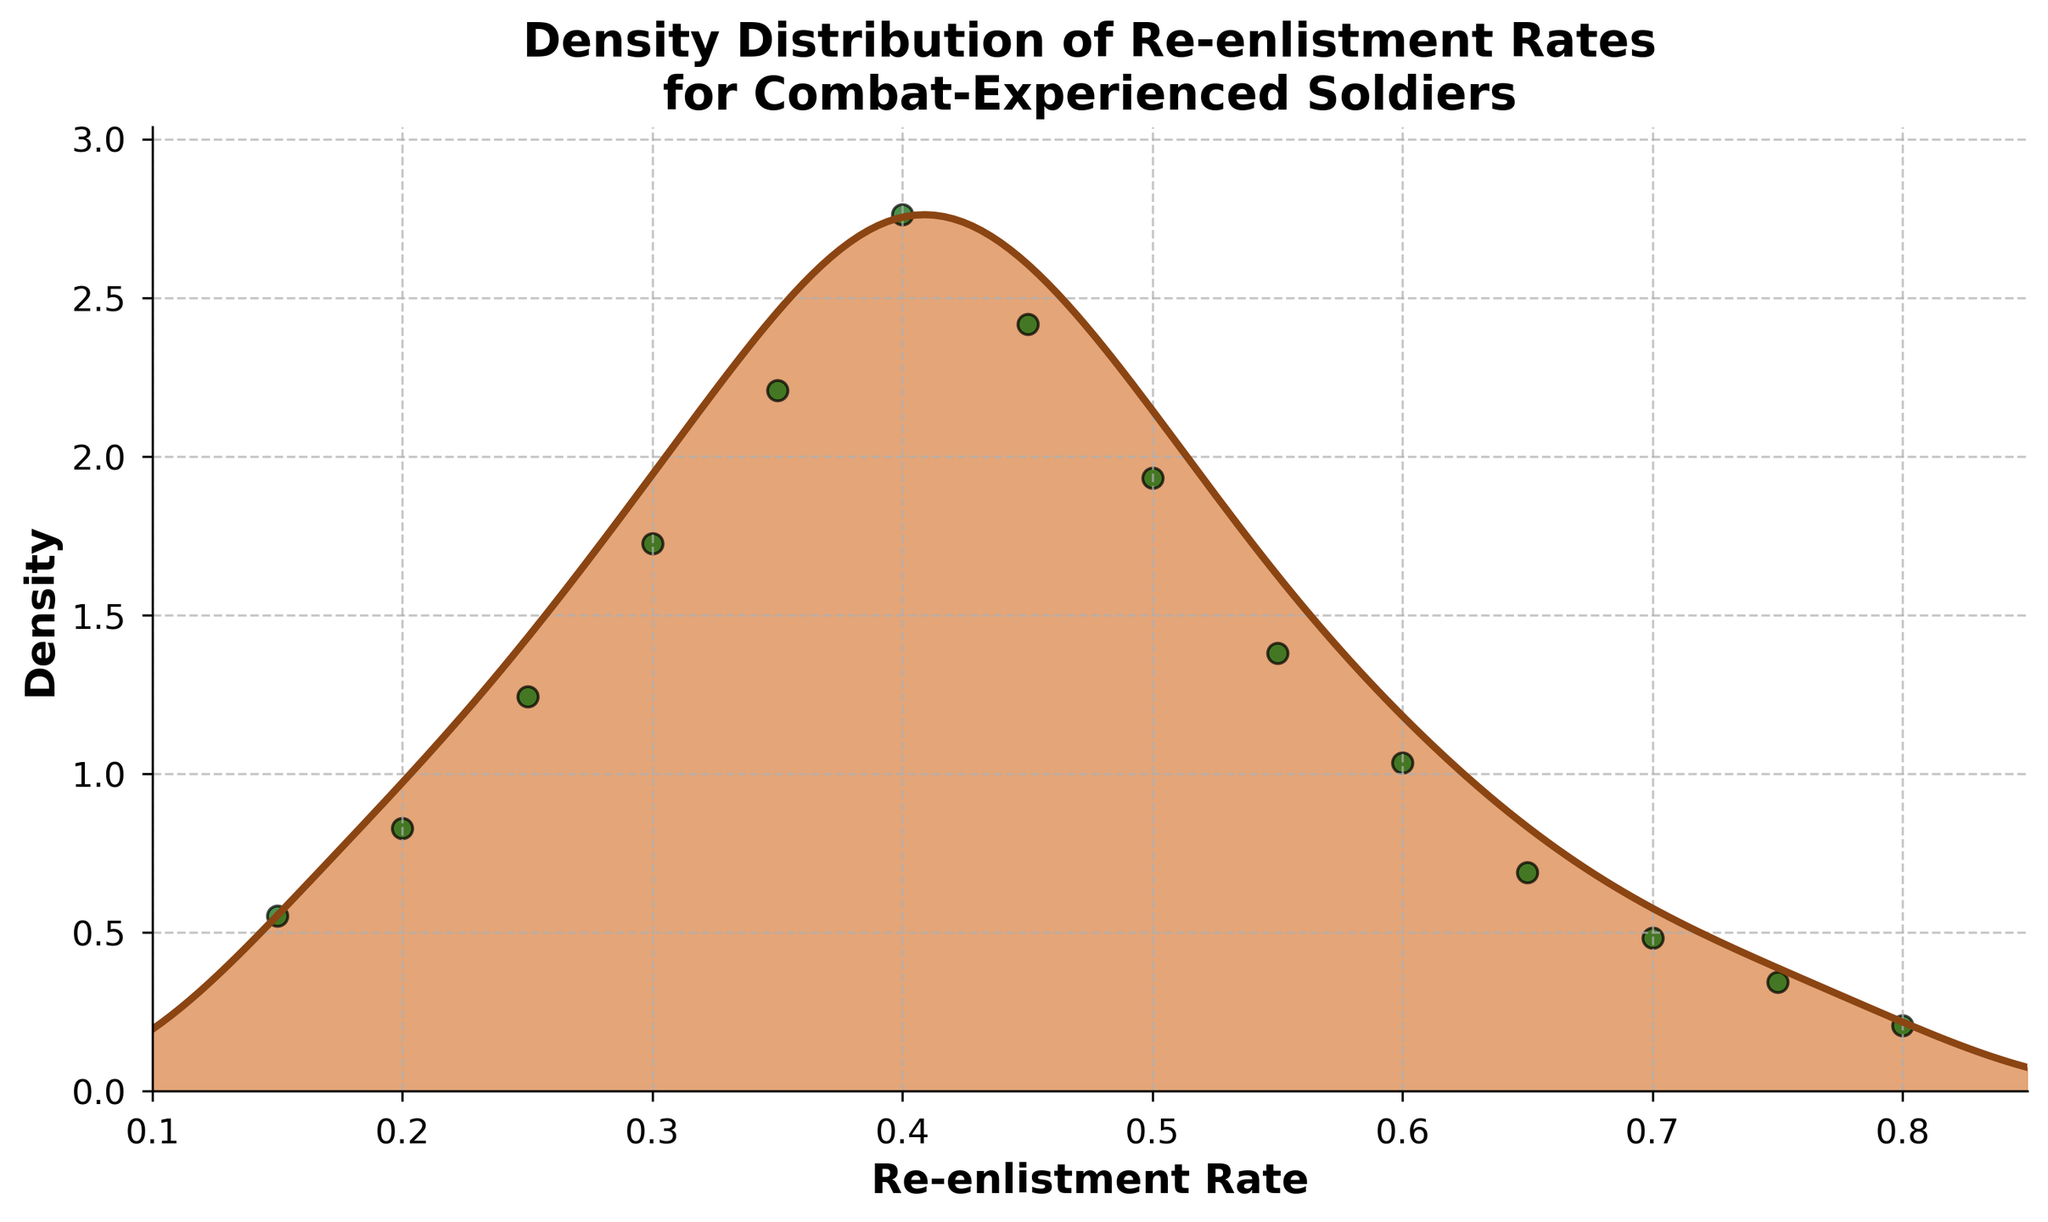What is the title of the plot? The title is typically found at the top of the plot. Here, it is placed prominently in bold font.
Answer: Density Distribution of Re-enlistment Rates for Combat-Experienced Soldiers What is the re-enlistment rate range that the plot covers? The x-axis, labeled 'Re-enlistment Rate' and showing the range on the plot, starts at 0.1 and ends at 0.85.
Answer: 0.1 to 0.85 What is the maximum frequency of re-enlistment rates displayed in the scatter plot? Looking at the scatter plot overlaid on the density plot, the highest y-value corresponds to 40 on the y-axis for frequency.
Answer: 40 At which re-enlistment rate does the peak density occur in the plot? The highest point on the density curve (where the curve reaches its maximum) is closest to a re-enlistment rate of approximately 0.40.
Answer: 0.40 How many distinct re-enlistment rates data points are plotted? The scatter plot shows individual data points. Counting them, we see 14 distinct re-enlistment rate data points.
Answer: 14 At which re-enlistment rate does the density curve start to decline significantly? The density curve continues to rise until about a re-enlistment rate of 0.40, after which it starts to decline significantly.
Answer: 0.40 At what re-enlistment rate does the density curve approximately reach half of its maximum value? The peak of the density curve is at 0.40. Half of this peak value on the y-axis occurs around the re-enlistment rates of 0.27 and 0.55 approximately.
Answer: Around 0.27 and 0.55 What is the relationship between the re-enlistment rates at 0.30 and 0.45 in terms of density? By examining the density curve at these points, the density at 0.30 is lower compared to the higher density at 0.45.
Answer: Density at 0.45 is higher than at 0.30 What color is used to fill the density curve? The filled area under the density curve is a shade of brown. This is observed visually from the filled region.
Answer: Brown What is the purpose of the scatter plot overlay? The scatter plot shows the actual frequency values for each re-enlistment rate, providing context to the density curve. This can be observed by comparing the scatter points with the density curve.
Answer: To show actual frequency values 